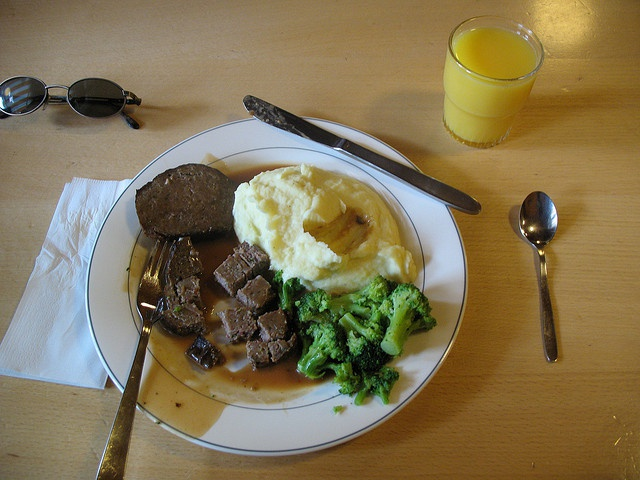Describe the objects in this image and their specific colors. I can see dining table in tan, olive, gray, and darkgray tones, broccoli in black, darkgreen, and green tones, cup in black, olive, and tan tones, fork in black, olive, and gray tones, and knife in black and gray tones in this image. 